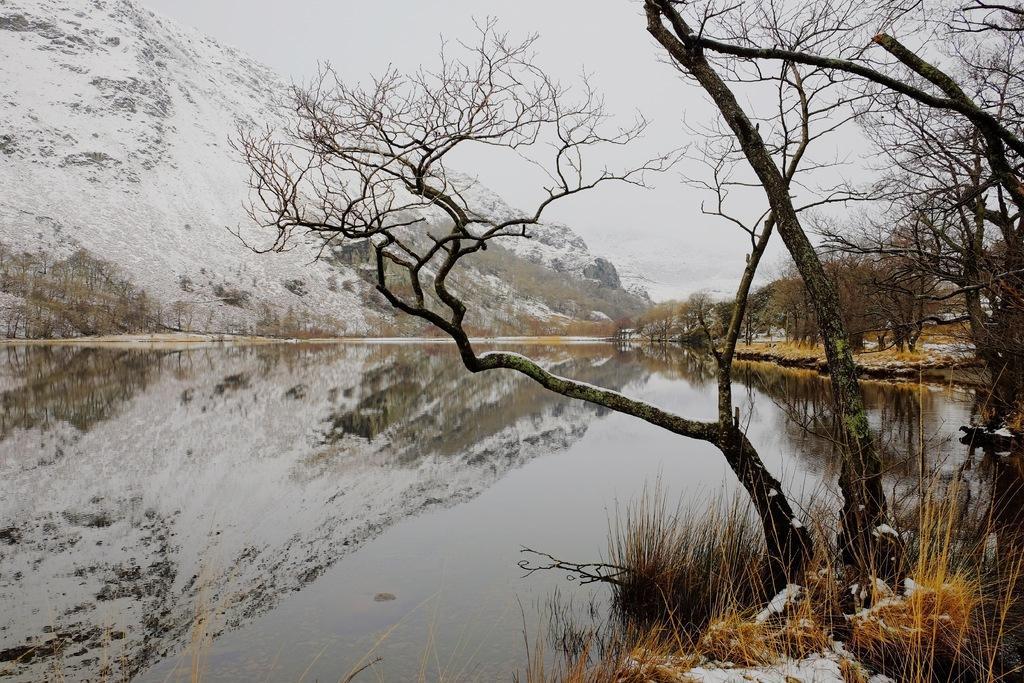How would you summarize this image in a sentence or two? In this picture I can see the water in front and on the right side bottom of this picture I see the grass and I see few trees. In the background I see the mountains and number of trees and I can also see the sky and I see the snow on the grass. 